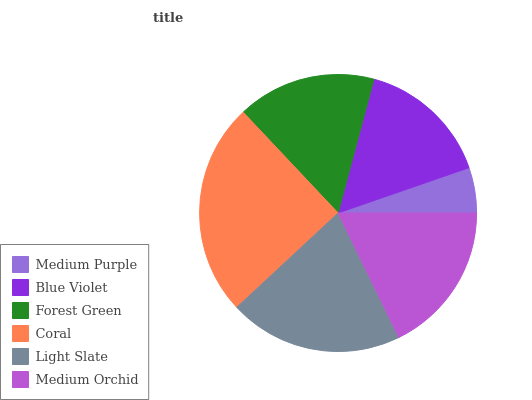Is Medium Purple the minimum?
Answer yes or no. Yes. Is Coral the maximum?
Answer yes or no. Yes. Is Blue Violet the minimum?
Answer yes or no. No. Is Blue Violet the maximum?
Answer yes or no. No. Is Blue Violet greater than Medium Purple?
Answer yes or no. Yes. Is Medium Purple less than Blue Violet?
Answer yes or no. Yes. Is Medium Purple greater than Blue Violet?
Answer yes or no. No. Is Blue Violet less than Medium Purple?
Answer yes or no. No. Is Medium Orchid the high median?
Answer yes or no. Yes. Is Forest Green the low median?
Answer yes or no. Yes. Is Forest Green the high median?
Answer yes or no. No. Is Blue Violet the low median?
Answer yes or no. No. 